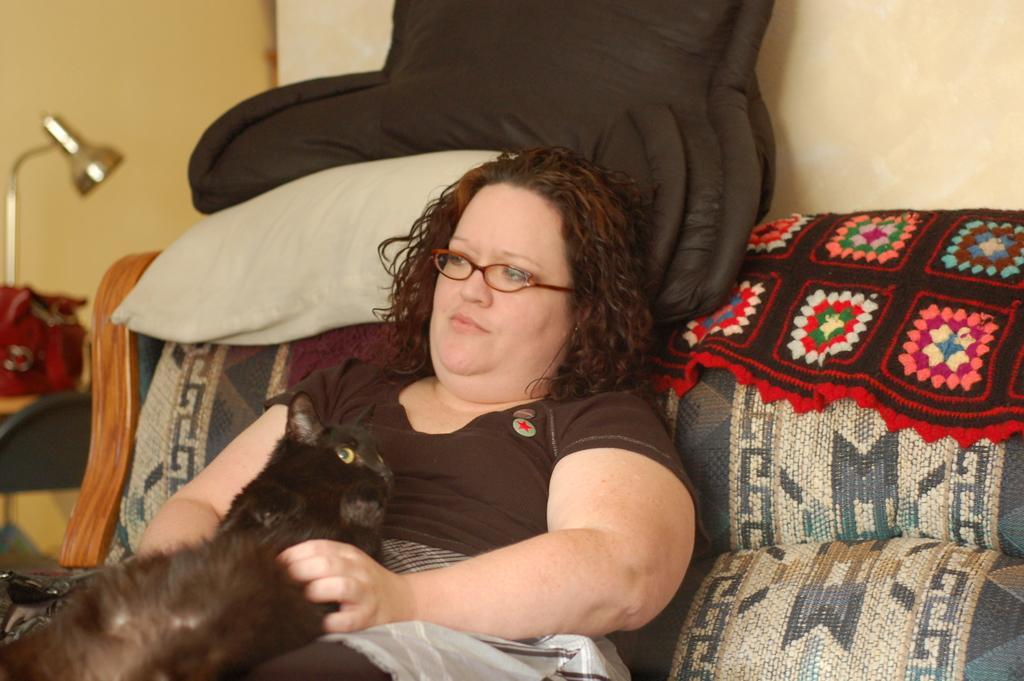How would you summarize this image in a sentence or two? In this image there is a person wearing brown dress sitting on the couch and there is a cat on her and at the background of the image there is a black color blanket. 